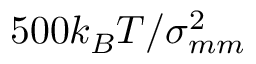Convert formula to latex. <formula><loc_0><loc_0><loc_500><loc_500>5 0 0 k _ { B } T / \sigma _ { m m } ^ { 2 }</formula> 